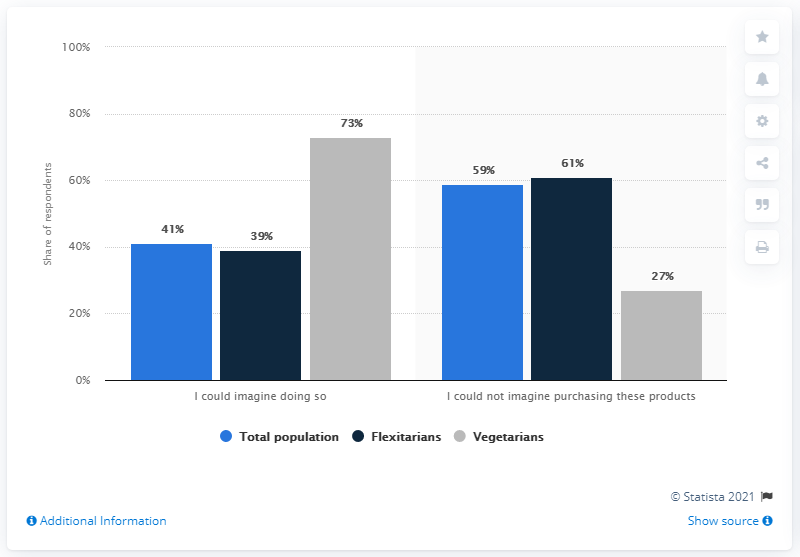Give some essential details in this illustration. A grey color bar is referred to as a symbol for vegetarians. The average of Flexitarians is 50. 